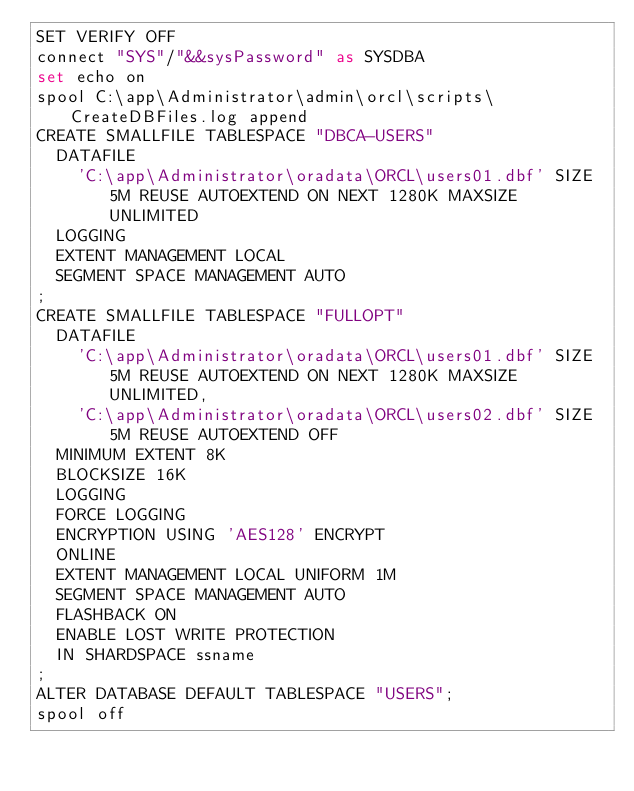Convert code to text. <code><loc_0><loc_0><loc_500><loc_500><_SQL_>SET VERIFY OFF
connect "SYS"/"&&sysPassword" as SYSDBA
set echo on
spool C:\app\Administrator\admin\orcl\scripts\CreateDBFiles.log append
CREATE SMALLFILE TABLESPACE "DBCA-USERS"
  DATAFILE
    'C:\app\Administrator\oradata\ORCL\users01.dbf' SIZE 5M REUSE AUTOEXTEND ON NEXT 1280K MAXSIZE UNLIMITED
  LOGGING
  EXTENT MANAGEMENT LOCAL
  SEGMENT SPACE MANAGEMENT AUTO
;
CREATE SMALLFILE TABLESPACE "FULLOPT"
  DATAFILE
    'C:\app\Administrator\oradata\ORCL\users01.dbf' SIZE 5M REUSE AUTOEXTEND ON NEXT 1280K MAXSIZE UNLIMITED,
    'C:\app\Administrator\oradata\ORCL\users02.dbf' SIZE 5M REUSE AUTOEXTEND OFF
  MINIMUM EXTENT 8K
  BLOCKSIZE 16K
  LOGGING
  FORCE LOGGING
  ENCRYPTION USING 'AES128' ENCRYPT
  ONLINE
  EXTENT MANAGEMENT LOCAL UNIFORM 1M
  SEGMENT SPACE MANAGEMENT AUTO
  FLASHBACK ON
  ENABLE LOST WRITE PROTECTION
  IN SHARDSPACE ssname
;
ALTER DATABASE DEFAULT TABLESPACE "USERS";
spool off
</code> 